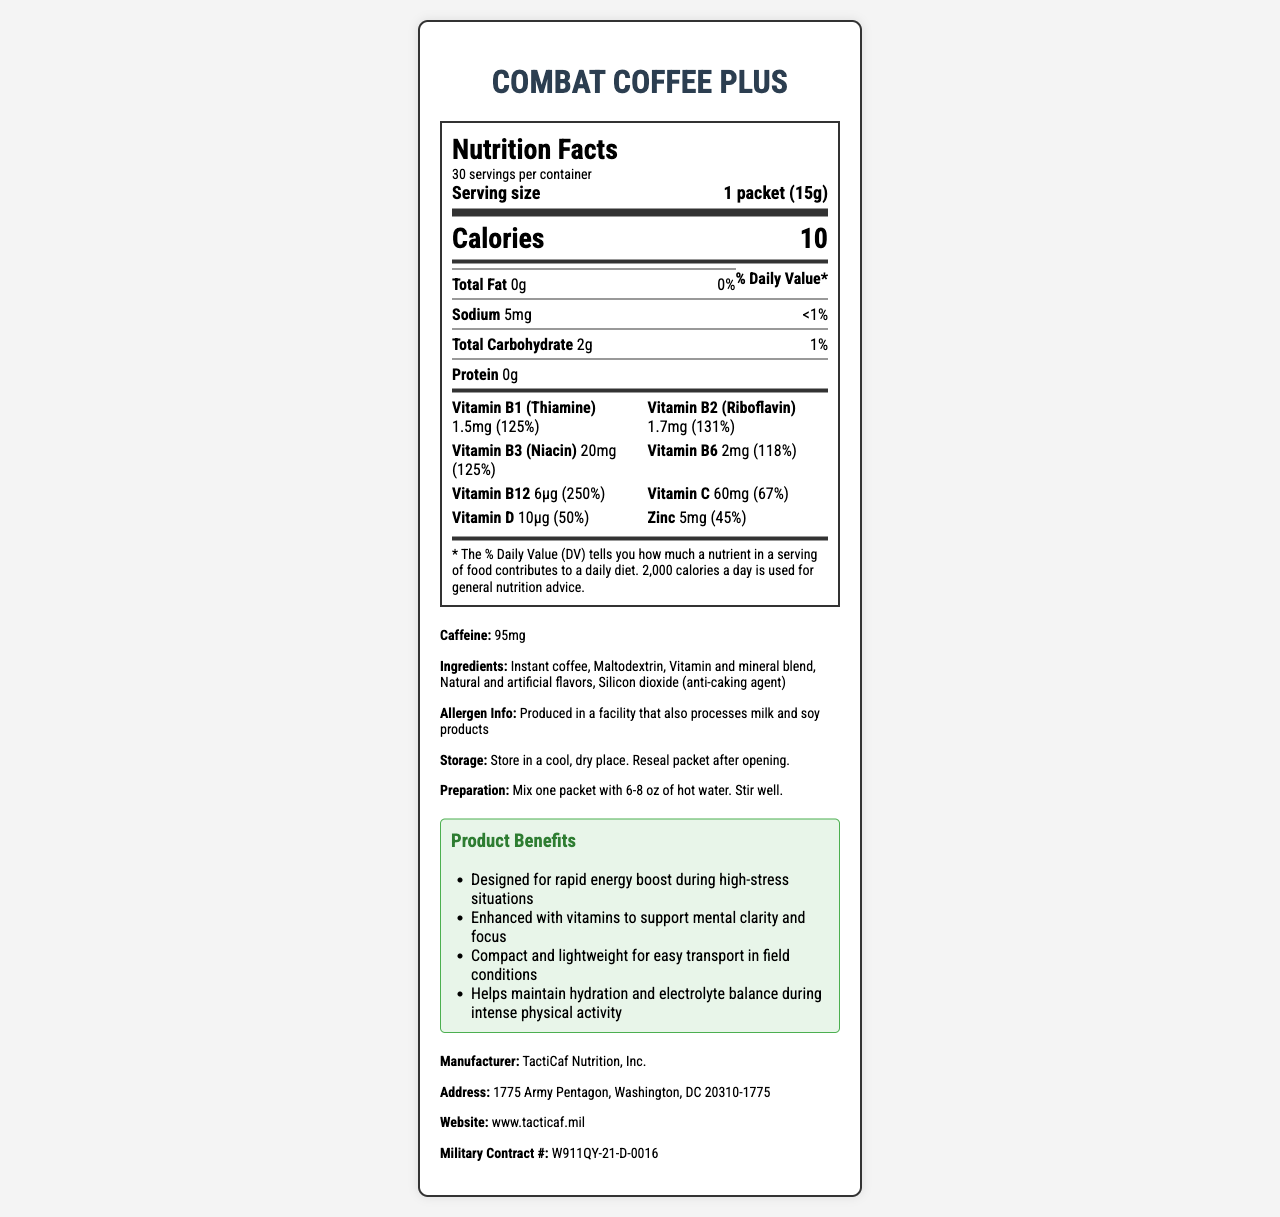who manufactures Combat Coffee Plus? The manufacturer is listed at the bottom of the document under the additional info section.
Answer: TactiCaf Nutrition, Inc. what is the caffeine content per serving? The caffeine content is listed in the additional info section.
Answer: 95mg how many vitamins and minerals are listed in the nutrients section? There are 8 vitamins and minerals listed in the nutrients section, each with their amount and daily value percentage.
Answer: 8 how many servings are in one container? The label states that there are 30 servings per container.
Answer: 30 what is the serving size? The serving size is stated as 1 packet (15g) in the nutrition label section.
Answer: 1 packet (15g) which vitamin has the highest daily value percentage? Vitamin B12 has a daily value of 250%, which is the highest listed on the label.
Answer: Vitamin B12 what is the amount of total carbohydrate per serving? A. 1g B. 2g C. 5g D. 10g The amount of total carbohydrate is listed as 2g per serving in the nutrition facts section.
Answer: B. 2g what is the daily value percentage for Vitamin C? A. 67% B. 125% C. 50% D. 118% The daily value percentage for Vitamin C is 67%, as listed in the vitamins and minerals section.
Answer: A. 67% is there protein in Combat Coffee Plus? The protein amount is listed as 0g in the nutrition facts section.
Answer: No is Combat Coffee Plus suitable for individuals with a soy allergy? The allergen info states that it is produced in a facility that also processes milk and soy, but it does not explicitly confirm if it is suitable for individuals with a soy allergy.
Answer: Cannot be determined describe the main idea of the document. The document provides comprehensive nutrition information and additional product details for Combat Coffee Plus, an instant coffee blend designed to enhance energy and focus for infantry soldiers.
Answer: The document is a Nutrition Facts Label for Combat Coffee Plus, an instant coffee blend enriched with vitamins and minerals designed for infantry units. It includes information about serving size, calories, nutrient content, ingredients, allergen information, storage, preparation instructions, product benefits, manufacturer, and additional details. what is the military contract number for Combat Coffee Plus? The military contract number is listed in the additional info section at the bottom of the document.
Answer: W911QY-21-D-0016 who is the intended consumer of Combat Coffee Plus as suggested by the document? The document includes references to high-stress situations, field conditions, and intense physical activity, suggesting it is designed for infantry soldiers.
Answer: Infantry soldiers 